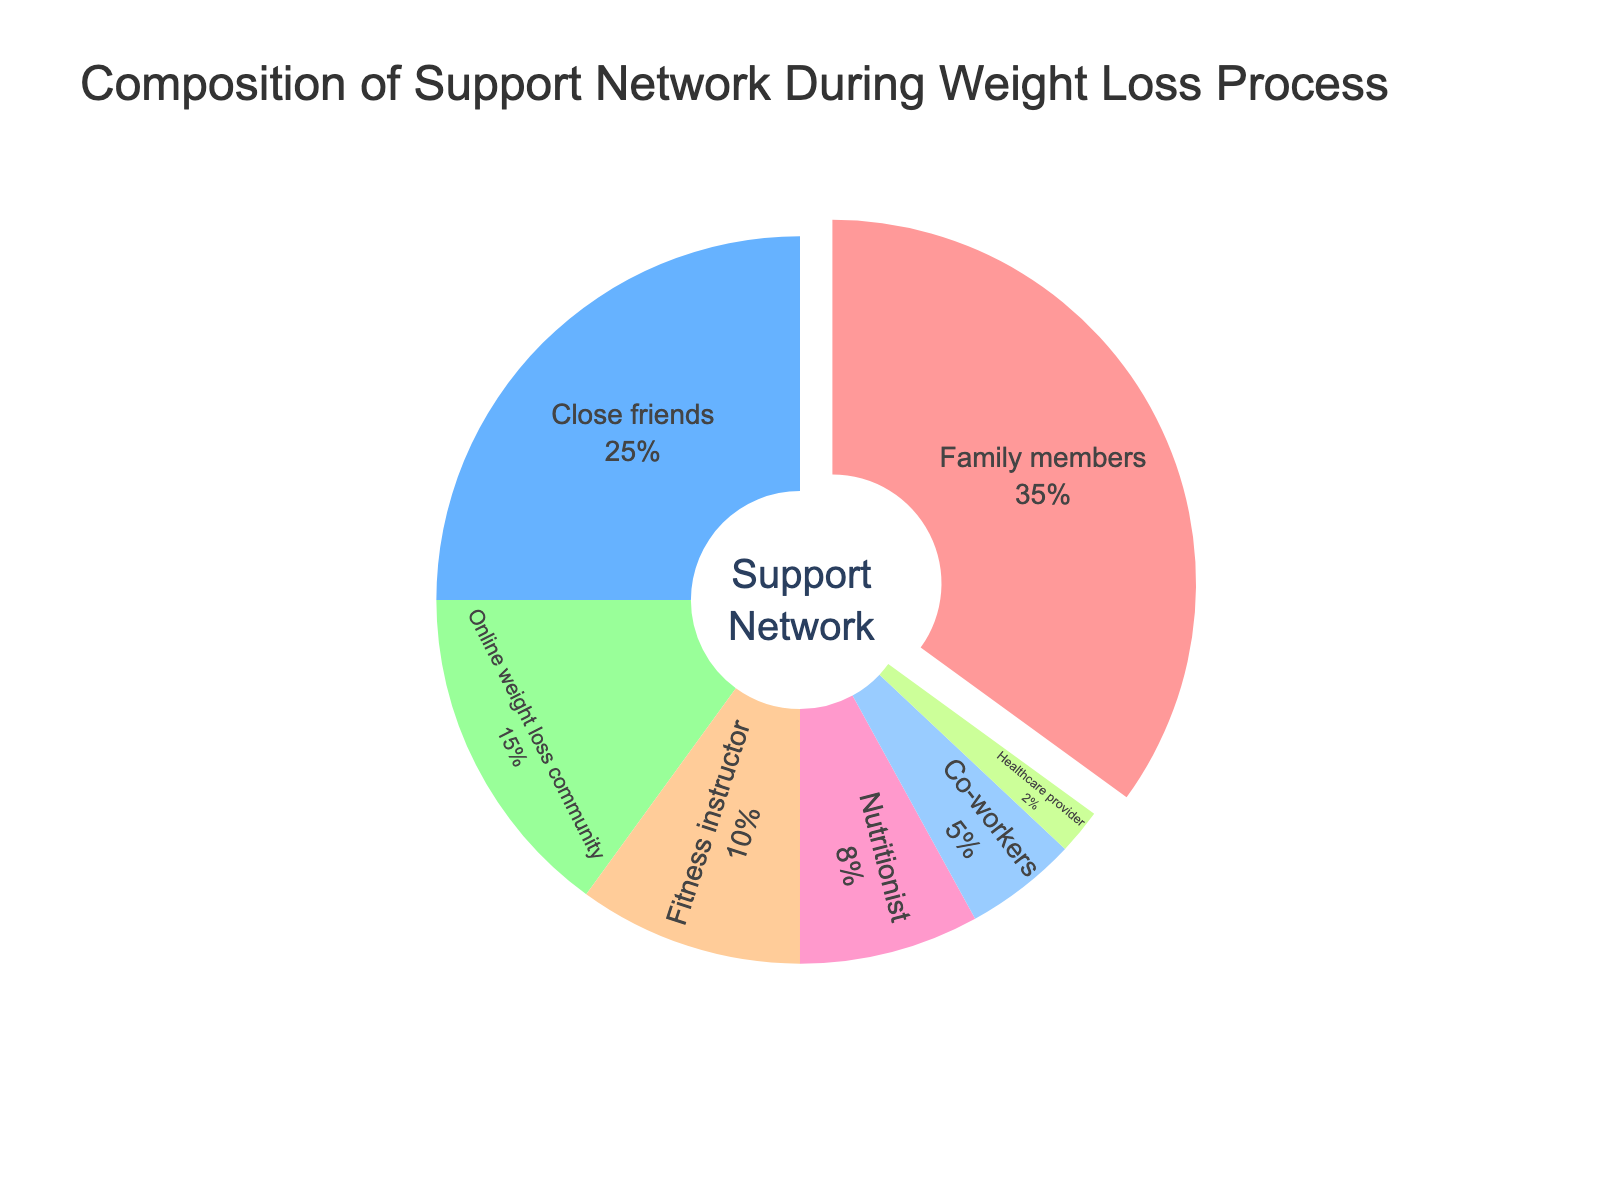What is the total percentage of support provided by Family members, Close friends, and Co-workers? Add the percentages of Family members (35%), Close friends (25%), and Co-workers (5%) together: 35 + 25 + 5 = 65%
Answer: 65% How much more support do Family members provide compared to Fitness instructors? Subtract the percentage of Fitness instructors (10%) from the percentage of Family members (35%): 35 - 10 = 25%
Answer: 25% Which category provides the least support? Look for the category with the smallest percentage. Healthcare provider has the lowest percentage at 2%
Answer: Healthcare provider What is the combined percentage of support given by Online weight loss community and Nutritionists? Add the percentages of Online weight loss community (15%) and Nutritionists (8%): 15 + 8 = 23%
Answer: 23% Is the percentage of support from Close friends greater than that from Fitness instructors and Nutritionists combined? Add the percentages of Fitness instructors (10%) and Nutritionists (8%): 10 + 8 = 18%. Compare this sum to the percentage for Close friends (25%). Since 25% > 18%, the answer is yes
Answer: Yes Identify the color representing Online weight loss community. The color associated with the Online weight loss community in the pie chart slice is green
Answer: Green What is the difference in support between the category that provides the second most support and the category that provides the third most support? Identify the second highest (Close friends, 25%) and third highest (Online weight loss community, 15%) percentages. Subtract the third highest from the second highest: 25 - 15 = 10%
Answer: 10% How much support do Fitness instructors and Healthcare providers provide together? Add the percentages of Fitness instructors (10%) and Healthcare providers (2%): 10 + 2 = 12%
Answer: 12% What percentage of support does the category with the largest slice of the pie chart represent? The largest slice of the pie chart belongs to Family members, which represents 35% of the support
Answer: 35% 